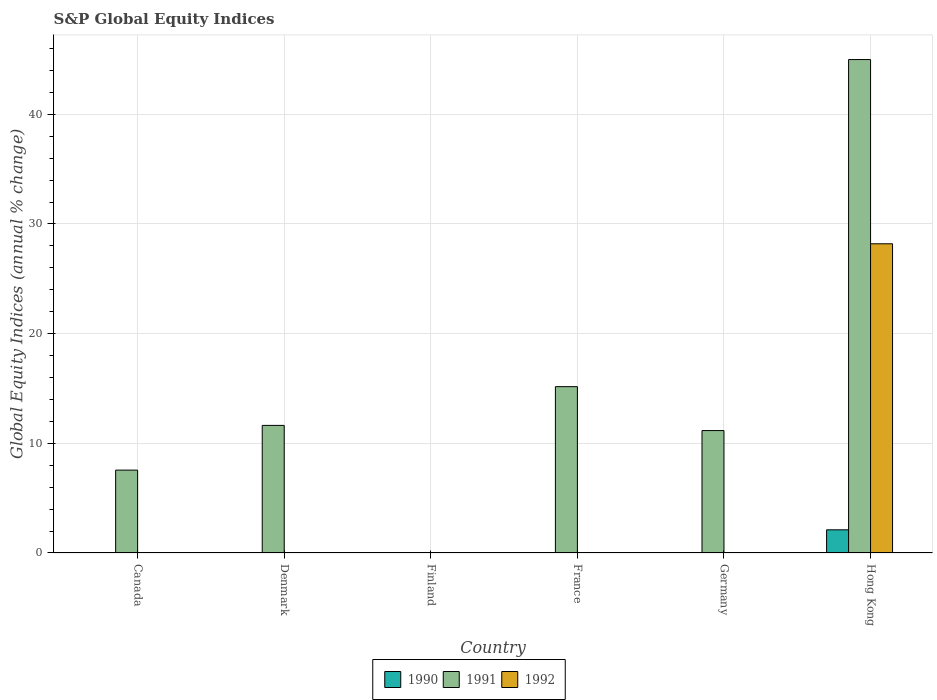How many different coloured bars are there?
Provide a short and direct response. 3. Are the number of bars per tick equal to the number of legend labels?
Provide a short and direct response. No. What is the label of the 1st group of bars from the left?
Your answer should be compact. Canada. What is the global equity indices in 1992 in Denmark?
Keep it short and to the point. 0. Across all countries, what is the maximum global equity indices in 1992?
Offer a very short reply. 28.19. Across all countries, what is the minimum global equity indices in 1992?
Your response must be concise. 0. In which country was the global equity indices in 1992 maximum?
Give a very brief answer. Hong Kong. What is the total global equity indices in 1991 in the graph?
Offer a very short reply. 90.51. What is the average global equity indices in 1991 per country?
Give a very brief answer. 15.09. What is the difference between the highest and the second highest global equity indices in 1991?
Provide a short and direct response. -33.36. What is the difference between the highest and the lowest global equity indices in 1991?
Offer a very short reply. 44.99. In how many countries, is the global equity indices in 1990 greater than the average global equity indices in 1990 taken over all countries?
Offer a very short reply. 1. Is the sum of the global equity indices in 1991 in Denmark and Hong Kong greater than the maximum global equity indices in 1990 across all countries?
Your response must be concise. Yes. Is it the case that in every country, the sum of the global equity indices in 1992 and global equity indices in 1991 is greater than the global equity indices in 1990?
Make the answer very short. No. How many countries are there in the graph?
Your response must be concise. 6. Are the values on the major ticks of Y-axis written in scientific E-notation?
Your answer should be compact. No. Does the graph contain any zero values?
Offer a very short reply. Yes. How are the legend labels stacked?
Offer a terse response. Horizontal. What is the title of the graph?
Give a very brief answer. S&P Global Equity Indices. Does "2012" appear as one of the legend labels in the graph?
Offer a terse response. No. What is the label or title of the X-axis?
Give a very brief answer. Country. What is the label or title of the Y-axis?
Offer a very short reply. Global Equity Indices (annual % change). What is the Global Equity Indices (annual % change) in 1991 in Canada?
Make the answer very short. 7.56. What is the Global Equity Indices (annual % change) in 1992 in Canada?
Offer a terse response. 0. What is the Global Equity Indices (annual % change) in 1991 in Denmark?
Offer a terse response. 11.63. What is the Global Equity Indices (annual % change) of 1990 in Finland?
Make the answer very short. 0. What is the Global Equity Indices (annual % change) in 1991 in Finland?
Offer a very short reply. 0. What is the Global Equity Indices (annual % change) in 1992 in Finland?
Offer a terse response. 0. What is the Global Equity Indices (annual % change) in 1991 in France?
Ensure brevity in your answer.  15.17. What is the Global Equity Indices (annual % change) of 1992 in France?
Ensure brevity in your answer.  0. What is the Global Equity Indices (annual % change) in 1990 in Germany?
Your response must be concise. 0. What is the Global Equity Indices (annual % change) of 1991 in Germany?
Keep it short and to the point. 11.16. What is the Global Equity Indices (annual % change) of 1992 in Germany?
Make the answer very short. 0. What is the Global Equity Indices (annual % change) of 1990 in Hong Kong?
Your answer should be very brief. 2.11. What is the Global Equity Indices (annual % change) of 1991 in Hong Kong?
Provide a succinct answer. 44.99. What is the Global Equity Indices (annual % change) in 1992 in Hong Kong?
Ensure brevity in your answer.  28.19. Across all countries, what is the maximum Global Equity Indices (annual % change) of 1990?
Ensure brevity in your answer.  2.11. Across all countries, what is the maximum Global Equity Indices (annual % change) in 1991?
Offer a very short reply. 44.99. Across all countries, what is the maximum Global Equity Indices (annual % change) of 1992?
Offer a very short reply. 28.19. Across all countries, what is the minimum Global Equity Indices (annual % change) of 1991?
Your answer should be very brief. 0. What is the total Global Equity Indices (annual % change) of 1990 in the graph?
Provide a succinct answer. 2.11. What is the total Global Equity Indices (annual % change) of 1991 in the graph?
Keep it short and to the point. 90.51. What is the total Global Equity Indices (annual % change) of 1992 in the graph?
Offer a very short reply. 28.19. What is the difference between the Global Equity Indices (annual % change) in 1991 in Canada and that in Denmark?
Provide a short and direct response. -4.08. What is the difference between the Global Equity Indices (annual % change) in 1991 in Canada and that in France?
Offer a terse response. -7.61. What is the difference between the Global Equity Indices (annual % change) of 1991 in Canada and that in Germany?
Your response must be concise. -3.61. What is the difference between the Global Equity Indices (annual % change) of 1991 in Canada and that in Hong Kong?
Your answer should be very brief. -37.44. What is the difference between the Global Equity Indices (annual % change) in 1991 in Denmark and that in France?
Your answer should be very brief. -3.53. What is the difference between the Global Equity Indices (annual % change) in 1991 in Denmark and that in Germany?
Keep it short and to the point. 0.47. What is the difference between the Global Equity Indices (annual % change) in 1991 in Denmark and that in Hong Kong?
Your answer should be compact. -33.36. What is the difference between the Global Equity Indices (annual % change) of 1991 in France and that in Germany?
Give a very brief answer. 4. What is the difference between the Global Equity Indices (annual % change) of 1991 in France and that in Hong Kong?
Provide a succinct answer. -29.83. What is the difference between the Global Equity Indices (annual % change) in 1991 in Germany and that in Hong Kong?
Make the answer very short. -33.83. What is the difference between the Global Equity Indices (annual % change) of 1991 in Canada and the Global Equity Indices (annual % change) of 1992 in Hong Kong?
Your answer should be very brief. -20.64. What is the difference between the Global Equity Indices (annual % change) in 1991 in Denmark and the Global Equity Indices (annual % change) in 1992 in Hong Kong?
Your response must be concise. -16.56. What is the difference between the Global Equity Indices (annual % change) in 1991 in France and the Global Equity Indices (annual % change) in 1992 in Hong Kong?
Ensure brevity in your answer.  -13.03. What is the difference between the Global Equity Indices (annual % change) in 1991 in Germany and the Global Equity Indices (annual % change) in 1992 in Hong Kong?
Provide a succinct answer. -17.03. What is the average Global Equity Indices (annual % change) of 1990 per country?
Provide a succinct answer. 0.35. What is the average Global Equity Indices (annual % change) of 1991 per country?
Your answer should be compact. 15.09. What is the average Global Equity Indices (annual % change) in 1992 per country?
Offer a terse response. 4.7. What is the difference between the Global Equity Indices (annual % change) of 1990 and Global Equity Indices (annual % change) of 1991 in Hong Kong?
Give a very brief answer. -42.88. What is the difference between the Global Equity Indices (annual % change) of 1990 and Global Equity Indices (annual % change) of 1992 in Hong Kong?
Offer a terse response. -26.08. What is the difference between the Global Equity Indices (annual % change) in 1991 and Global Equity Indices (annual % change) in 1992 in Hong Kong?
Your answer should be compact. 16.8. What is the ratio of the Global Equity Indices (annual % change) in 1991 in Canada to that in Denmark?
Your answer should be compact. 0.65. What is the ratio of the Global Equity Indices (annual % change) of 1991 in Canada to that in France?
Provide a succinct answer. 0.5. What is the ratio of the Global Equity Indices (annual % change) of 1991 in Canada to that in Germany?
Provide a succinct answer. 0.68. What is the ratio of the Global Equity Indices (annual % change) in 1991 in Canada to that in Hong Kong?
Ensure brevity in your answer.  0.17. What is the ratio of the Global Equity Indices (annual % change) of 1991 in Denmark to that in France?
Your response must be concise. 0.77. What is the ratio of the Global Equity Indices (annual % change) of 1991 in Denmark to that in Germany?
Provide a succinct answer. 1.04. What is the ratio of the Global Equity Indices (annual % change) in 1991 in Denmark to that in Hong Kong?
Offer a very short reply. 0.26. What is the ratio of the Global Equity Indices (annual % change) in 1991 in France to that in Germany?
Give a very brief answer. 1.36. What is the ratio of the Global Equity Indices (annual % change) of 1991 in France to that in Hong Kong?
Your response must be concise. 0.34. What is the ratio of the Global Equity Indices (annual % change) of 1991 in Germany to that in Hong Kong?
Offer a very short reply. 0.25. What is the difference between the highest and the second highest Global Equity Indices (annual % change) in 1991?
Your answer should be very brief. 29.83. What is the difference between the highest and the lowest Global Equity Indices (annual % change) of 1990?
Offer a terse response. 2.11. What is the difference between the highest and the lowest Global Equity Indices (annual % change) of 1991?
Give a very brief answer. 44.99. What is the difference between the highest and the lowest Global Equity Indices (annual % change) of 1992?
Your answer should be very brief. 28.19. 